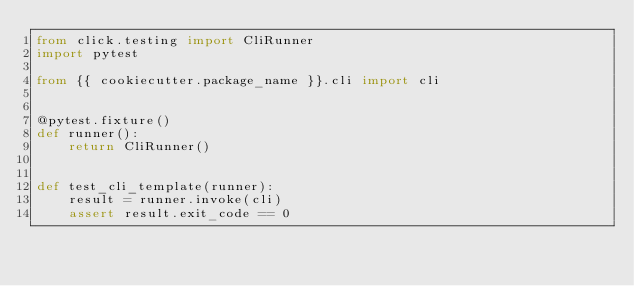<code> <loc_0><loc_0><loc_500><loc_500><_Python_>from click.testing import CliRunner
import pytest

from {{ cookiecutter.package_name }}.cli import cli


@pytest.fixture()
def runner():
    return CliRunner()


def test_cli_template(runner):
    result = runner.invoke(cli)
    assert result.exit_code == 0
</code> 